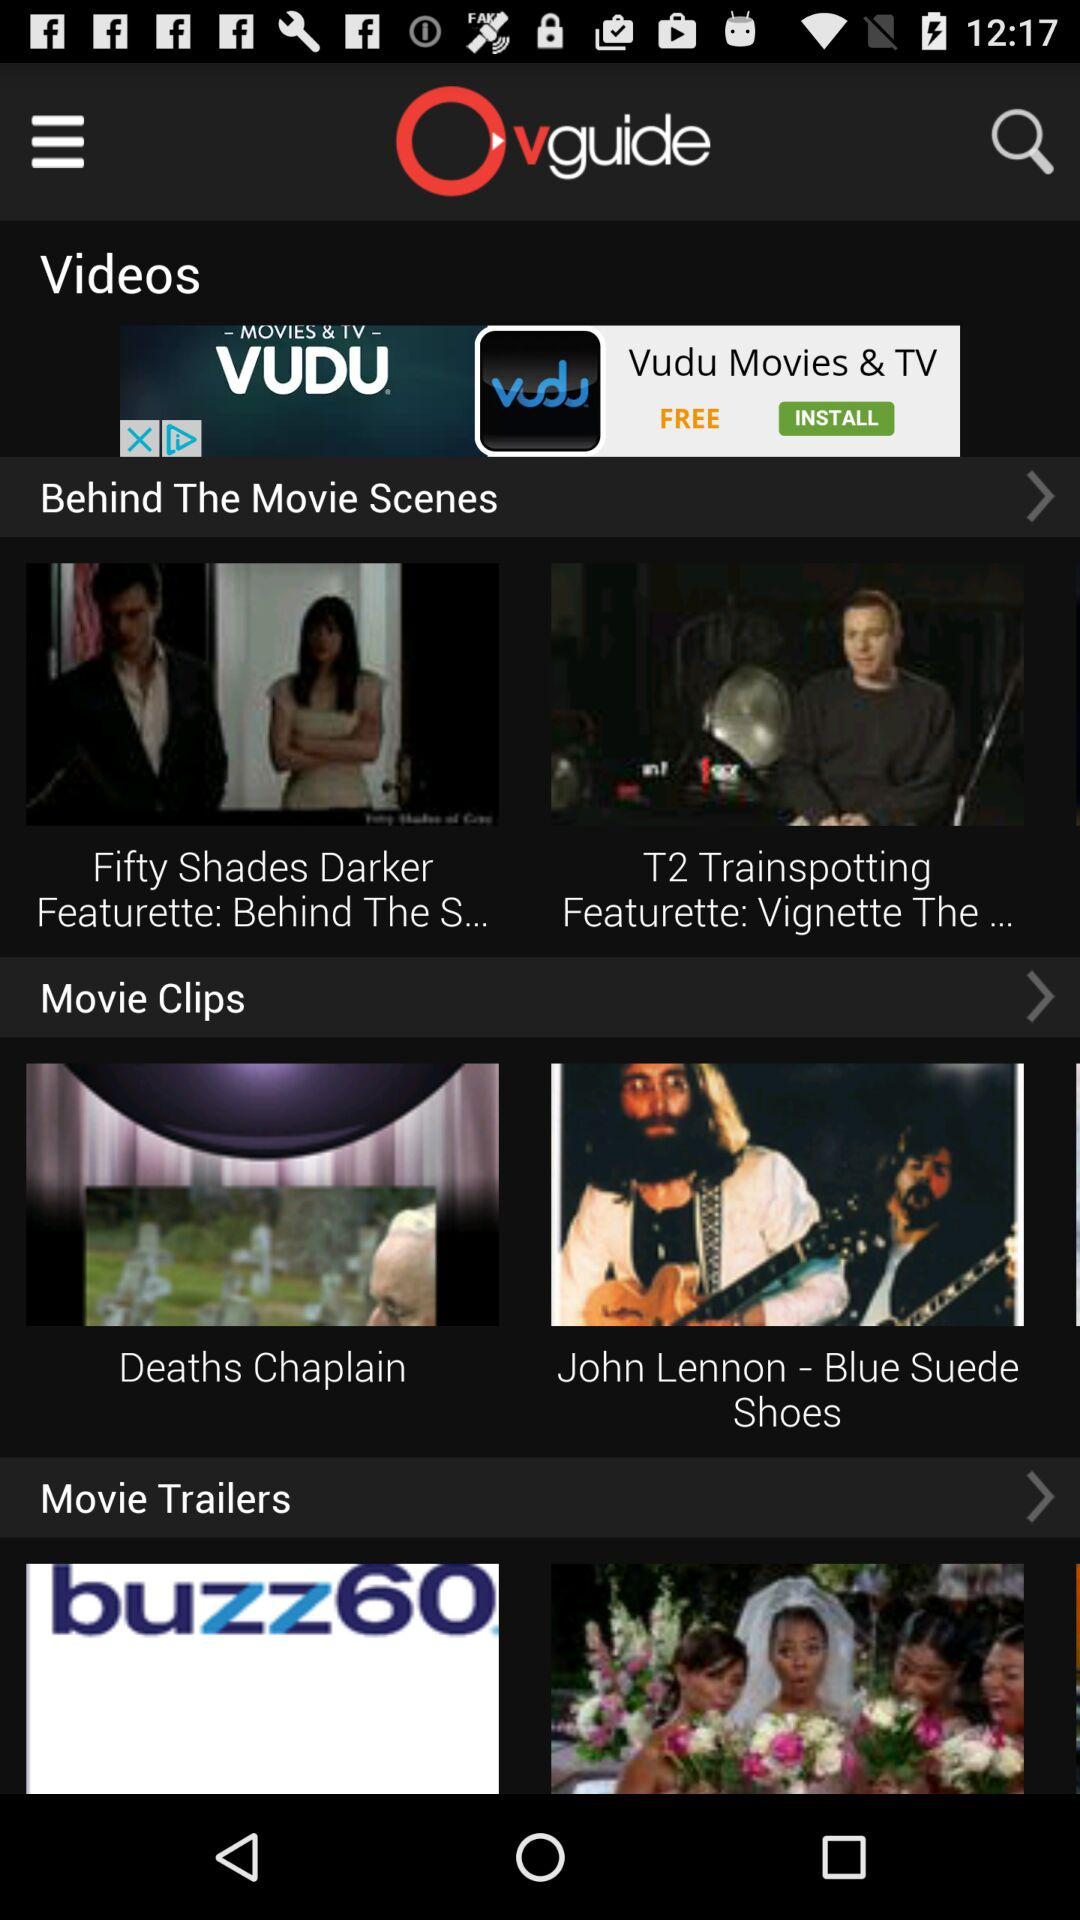What is the application name? The application name is "vguide". 